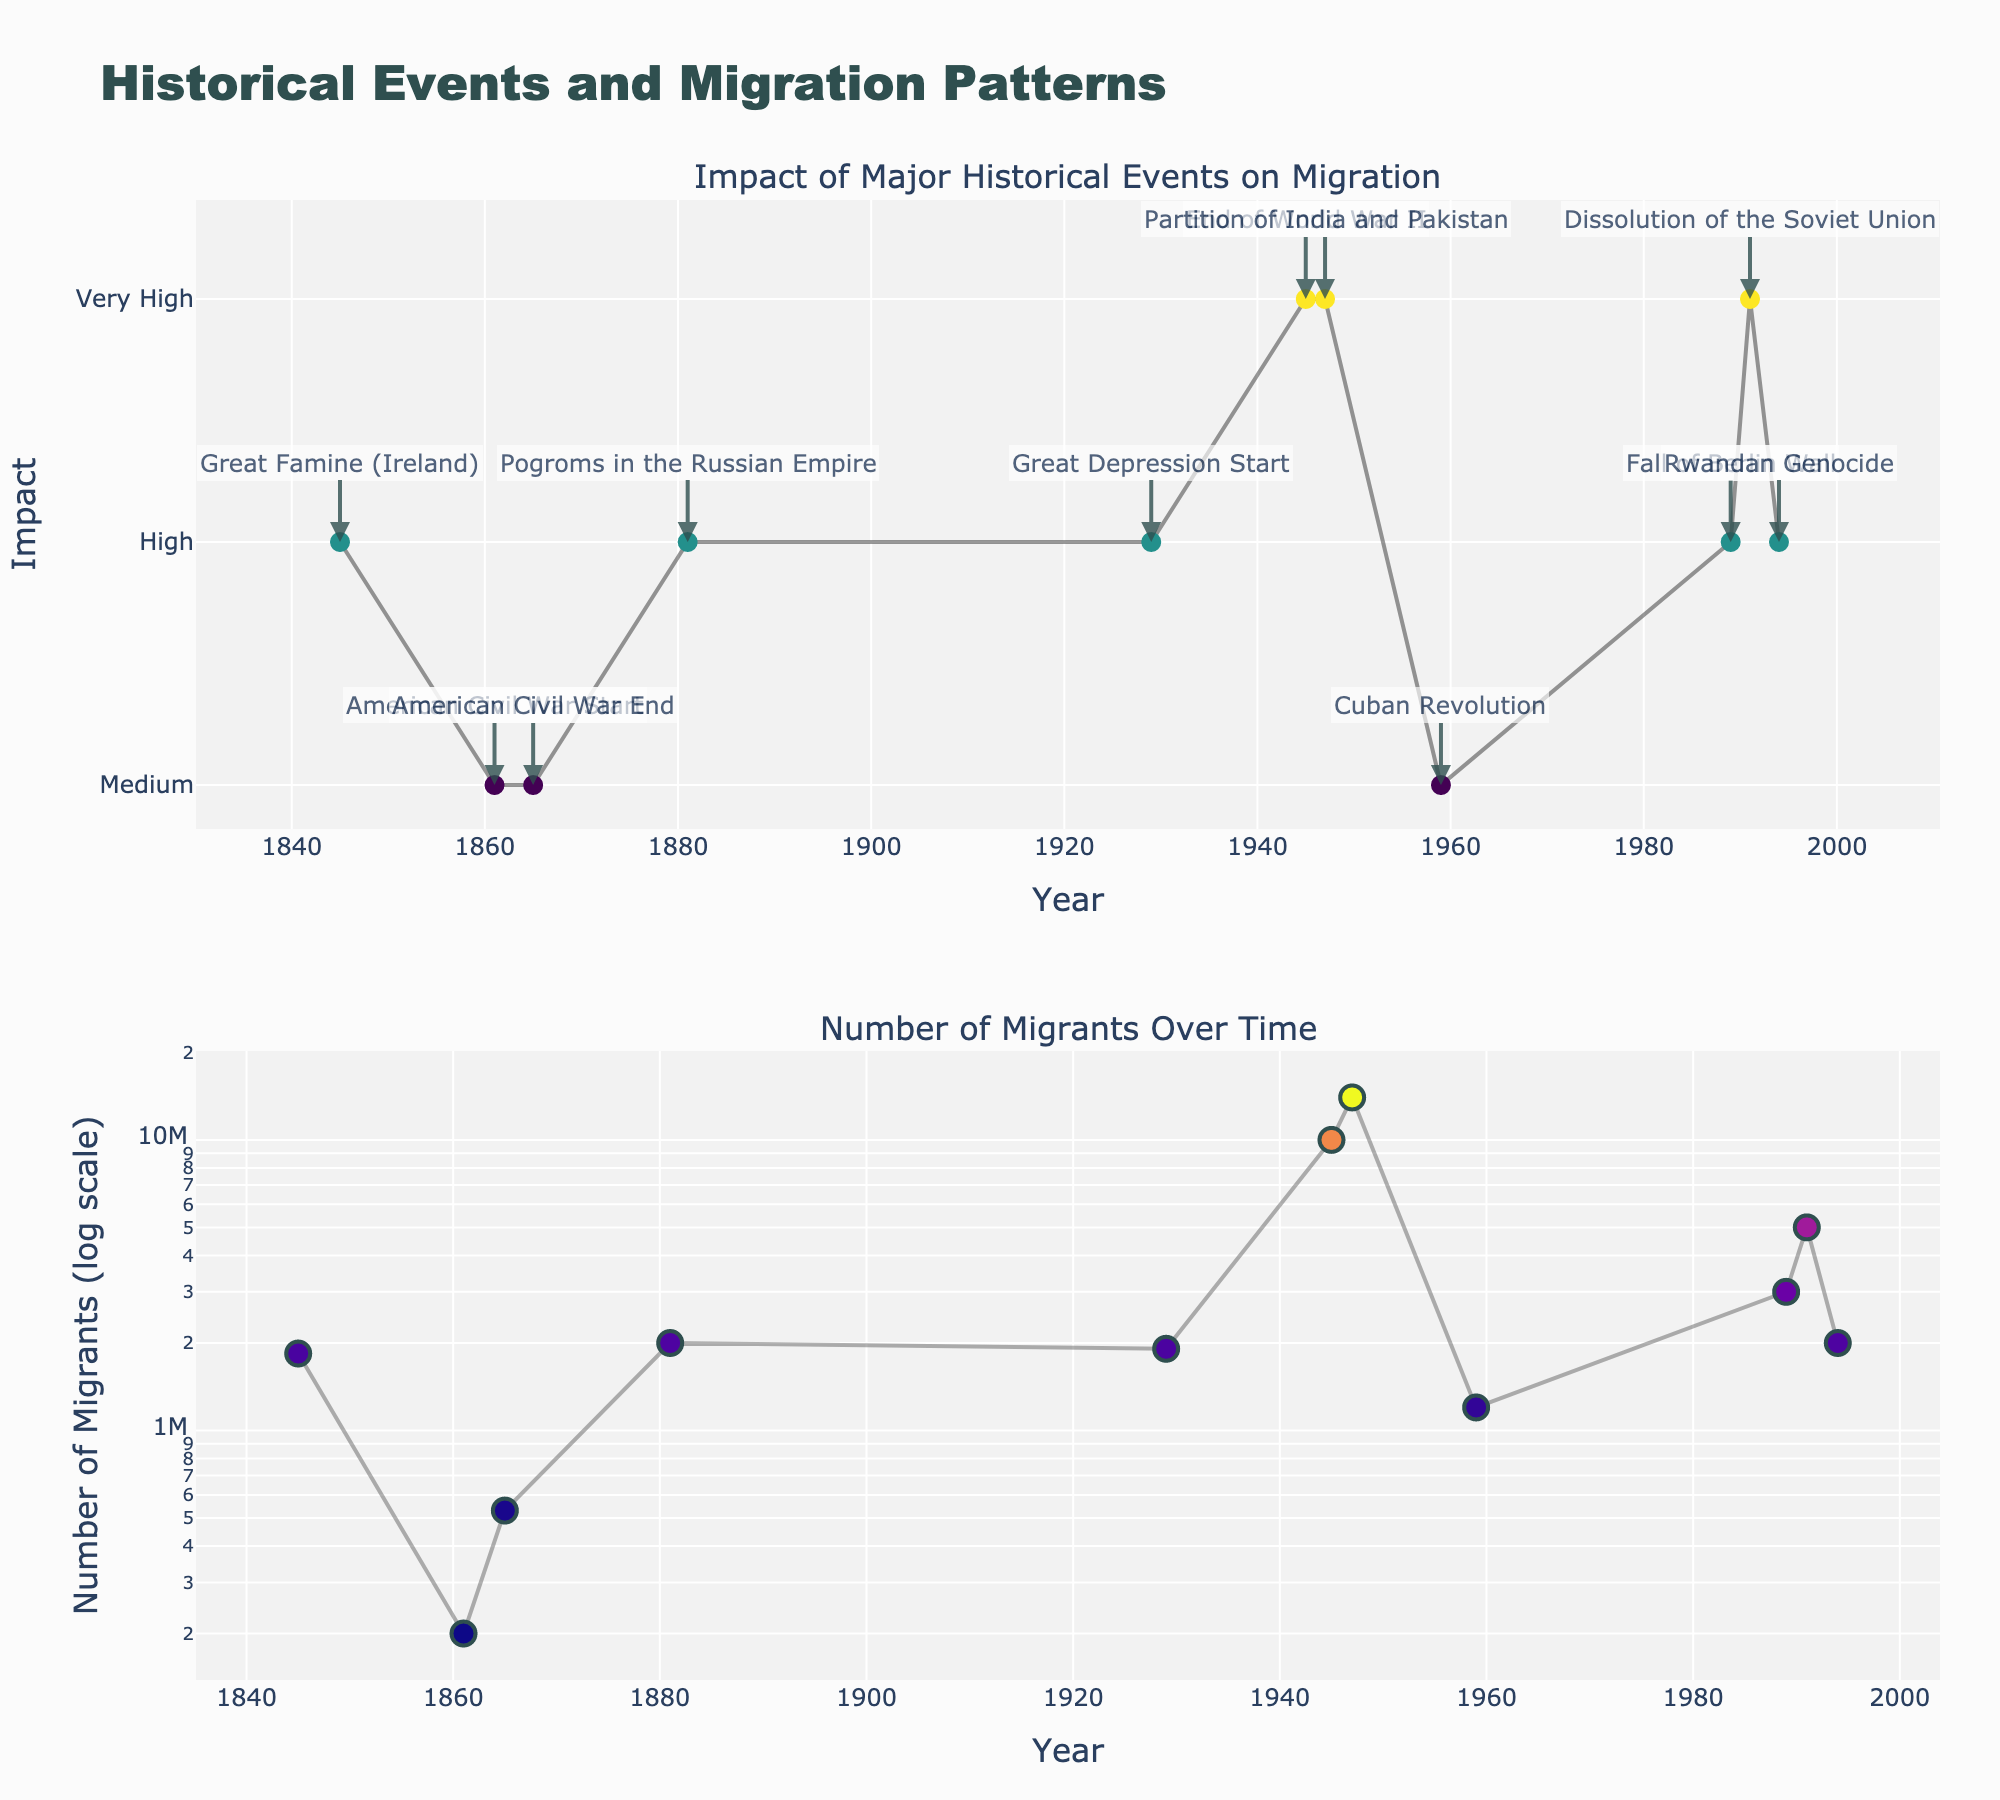What is the title of the figure? The title of the figure is usually located at the top. In this case, it reads "Historical Events and Migration Patterns".
Answer: Historical Events and Migration Patterns What are the y-axis labels for the top subplot? The y-axis labels for the top subplot are found on the left side of the top chart. They indicate different levels of impact: 'Medium', 'High', and 'Very High'.
Answer: Medium, High, Very High What is the maximum number of migrants shown on the log scale? The maximum number of migrants can be observed on the log scale of the bottom subplot. The highest point, as indicated by the y-axis, is 14,000,000 for the Partition of India and Pakistan in 1947.
Answer: 14,000,000 How many datapoints represent events with a 'Very High' impact? The data points with 'Very High' impact can be seen by looking at the points on the top subplot with a y-value corresponding to 'Very High' (3). Counting these points gives 4 events.
Answer: 4 Which historical event had the lowest number of migrants and how many were there? To find the lowest number of migrants, look at the bottom subplot for the smallest y-value on the log scale. The lowest point represents the start of the American Civil War in 1861 with 200,000 migrants.
Answer: American Civil War Start, 200,000 Between which years did the number of migrants increase the most rapidly? We need to identify the years with the steepest slope on the bottom subplot. The most rapid increase in migrants can be seen between 1945 (End of World War II) and 1947 (Partition of India and Pakistan), where the number of migrants jumps from 10,000,000 to 14,000,000.
Answer: 1945 to 1947 Which event resulted in a similar number of migrants to the Pogroms in the Russian Empire? Look for the data point in the bottom subplot with the same y-value as the Pogroms in the Russian Empire (2,000,000 migrants). The Rwandan Genocide in 1994 also had 2,000,000 migrants.
Answer: Rwandan Genocide How did the impact of the Great Depression compare to that of the Cuban Revolution? Compare the y-values on the top subplot for the events corresponding to the Great Depression and the Cuban Revolution. The impact of the Great Depression is 'High' whereas the Cuban Revolution has a 'Medium' impact.
Answer: Great Depression impact is higher Which event had the highest impact and also generated the highest number of migrants? Look for the data point that appears at the top of both subplots: Partition of India and Pakistan in 1947 (Very High impact and 14,000,000 migrants).
Answer: Partition of India and Pakistan 